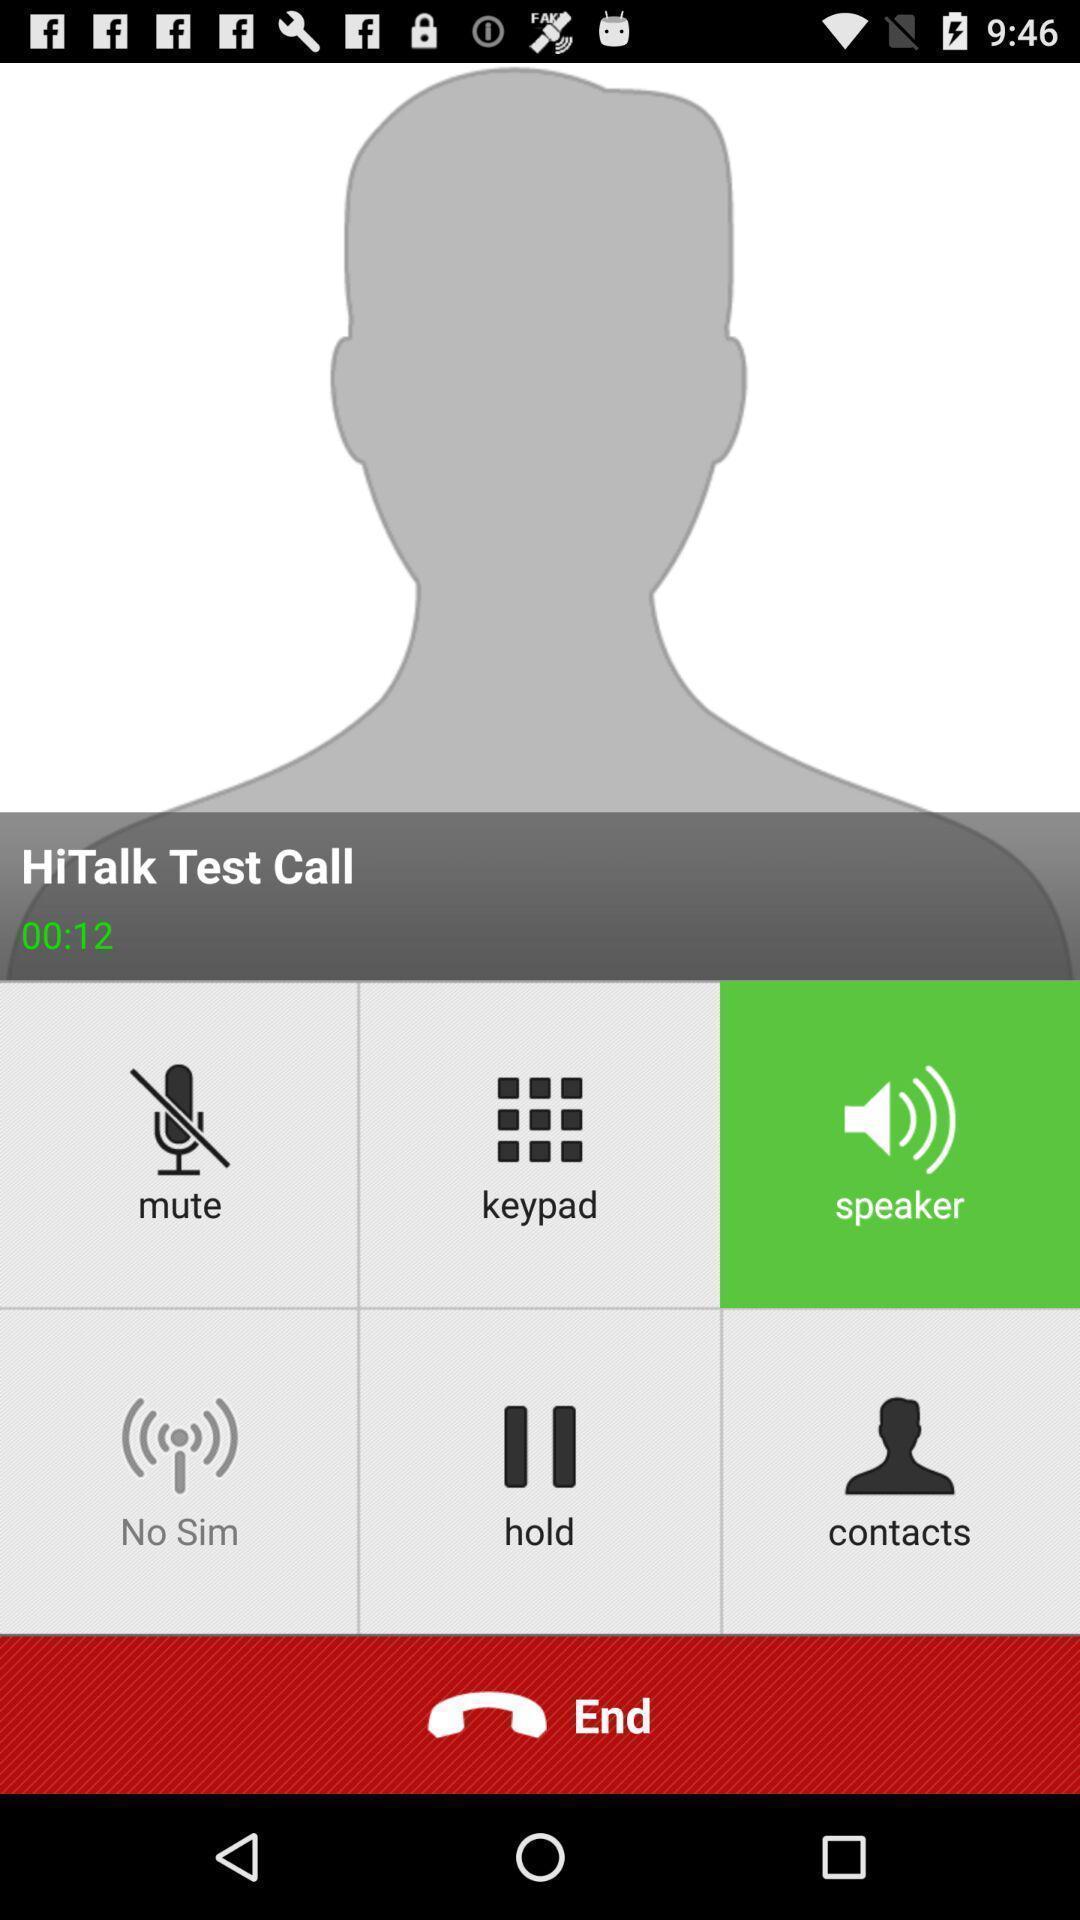Explain the elements present in this screenshot. Screen showing test call page. 